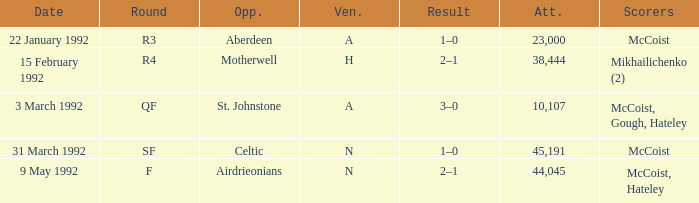In which venue was round F? N. 